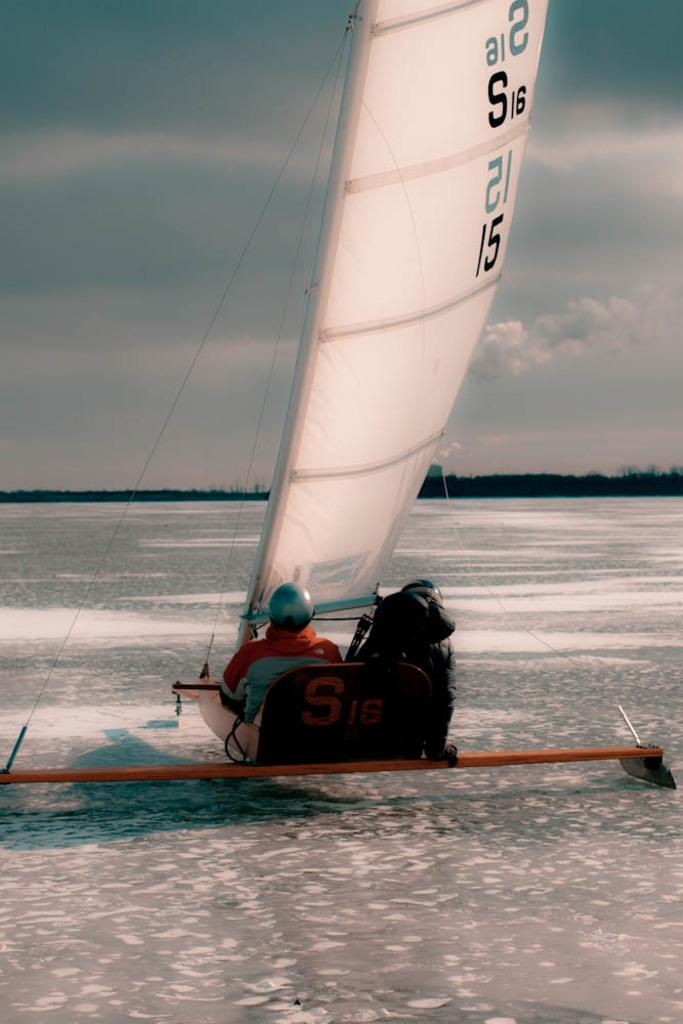How many people are in the image? There are two persons in the image. What are the persons doing in the image? The persons are sitting on a skateboard. What is on the ground in the image? There is ice on the floor. What can be seen in the background of the image? There are trees in the background of the image. What is the condition of the sky in the image? The sky is clear in the image. What type of debt is being discussed by the persons sitting on the skateboard in the image? There is no indication in the image that the persons are discussing debt or any financial matters. 